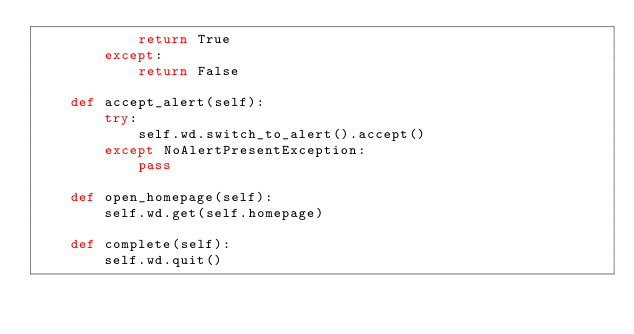<code> <loc_0><loc_0><loc_500><loc_500><_Python_>            return True
        except:
            return False

    def accept_alert(self):
        try:
            self.wd.switch_to_alert().accept()
        except NoAlertPresentException:
            pass

    def open_homepage(self):
        self.wd.get(self.homepage)

    def complete(self):
        self.wd.quit()
</code> 